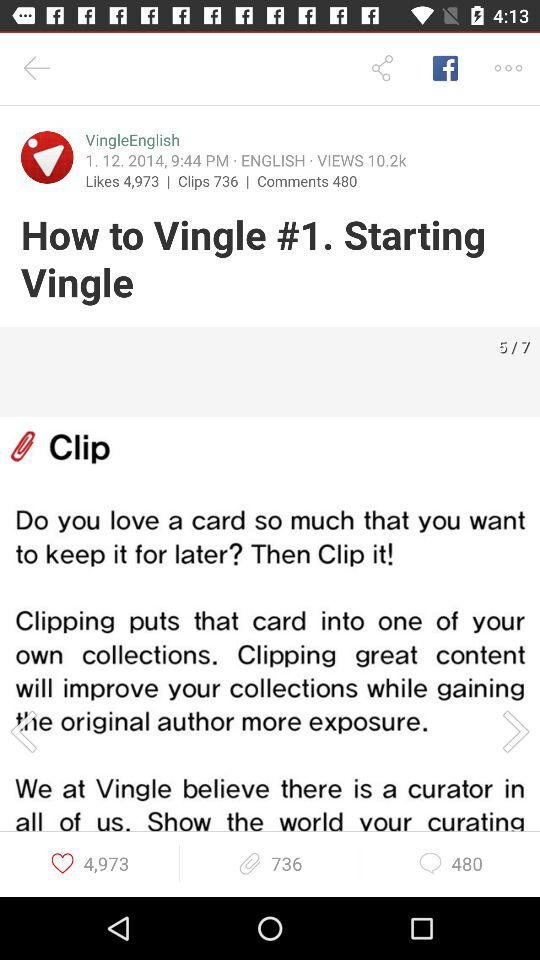What is the topic name? The topic name is "How to Vingle #1. Starting Vingle". 